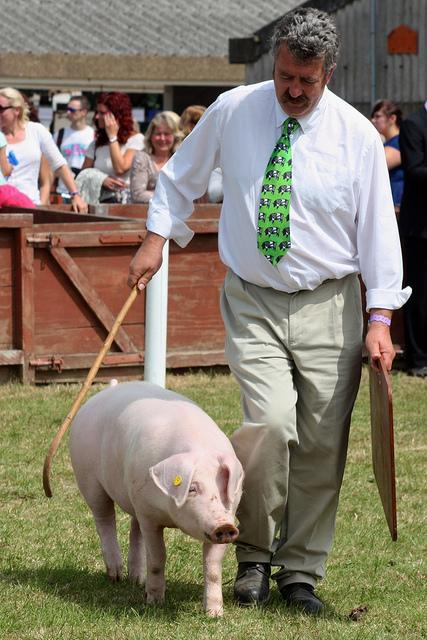What is the pig here entered in? contest 